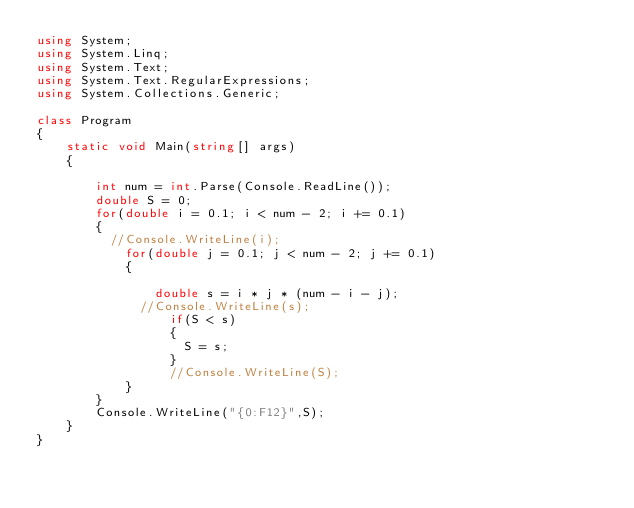<code> <loc_0><loc_0><loc_500><loc_500><_C#_>using System;
using System.Linq;
using System.Text;
using System.Text.RegularExpressions;
using System.Collections.Generic;

class Program
{
    static void Main(string[] args)
    {

        int num = int.Parse(Console.ReadLine());
      	double S = 0;
	    for(double i = 0.1; i < num - 2; i += 0.1)
        {
          //Console.WriteLine(i);
        	for(double j = 0.1; j < num - 2; j += 0.1)
        	{
        		
        		double s = i * j * (num - i - j);
              //Console.WriteLine(s);
                  if(S < s)
                  {
                  	S = s;
                  }
                  //Console.WriteLine(S);
        	}
        }
        Console.WriteLine("{0:F12}",S);
    }
}</code> 